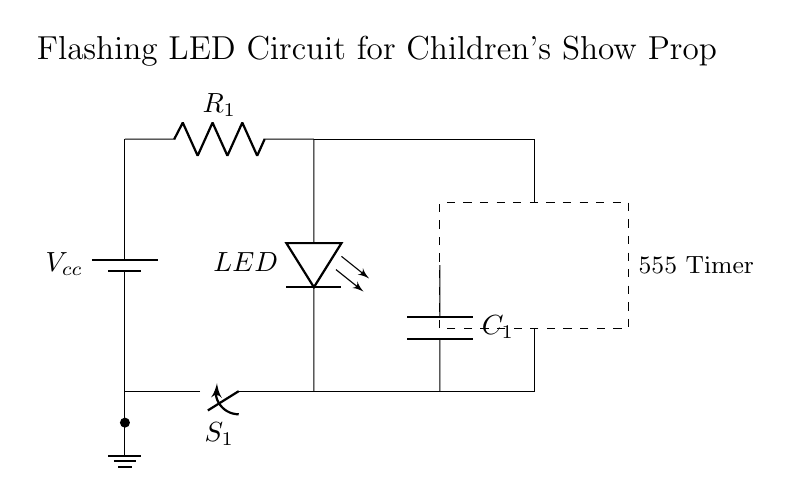What component controls the flashing effect? The 555 Timer IC is responsible for generating the timing signals that create the flashing effect. The circuit configuration uses the timer to switch the LED on and off intermittently.
Answer: 555 Timer What is the role of the resistor in this circuit? The resistor limits the current flowing through the LED, preventing it from drawing too much current and getting damaged. A proper resistor value ensures safe operation of the LED.
Answer: Current limiting What type of switch is used in the circuit? The circuit uses a single-pole, single-throw switch (SPST), which allows for simple on/off control of the LED by completing or breaking the circuit.
Answer: SPST How many components are in the circuit? The circuit consists of four primary components: a battery, a resistor, a LED, and a 555 timer. Each serves a distinct purpose in making the circuit functional for flashing the LED.
Answer: Four What does the capacitor do in this circuit? The capacitor stores and releases electrical energy, helping control the timing intervals for the LED operation by smoothing the output from the 555 Timer. This leads to a consistent flashing effect.
Answer: Timing control What is the voltage source in this circuit? The circuit is powered by a voltage source labeled Vcc, which supplies the necessary energy for the circuit's operation, including the LED and the 555 Timer.
Answer: Vcc Which part of the circuit is grounded? The ground connection is established at the bottom of the circuit, where the negative side of the battery and the LED's cathode are connected, providing a reference point for voltage levels.
Answer: Ground 